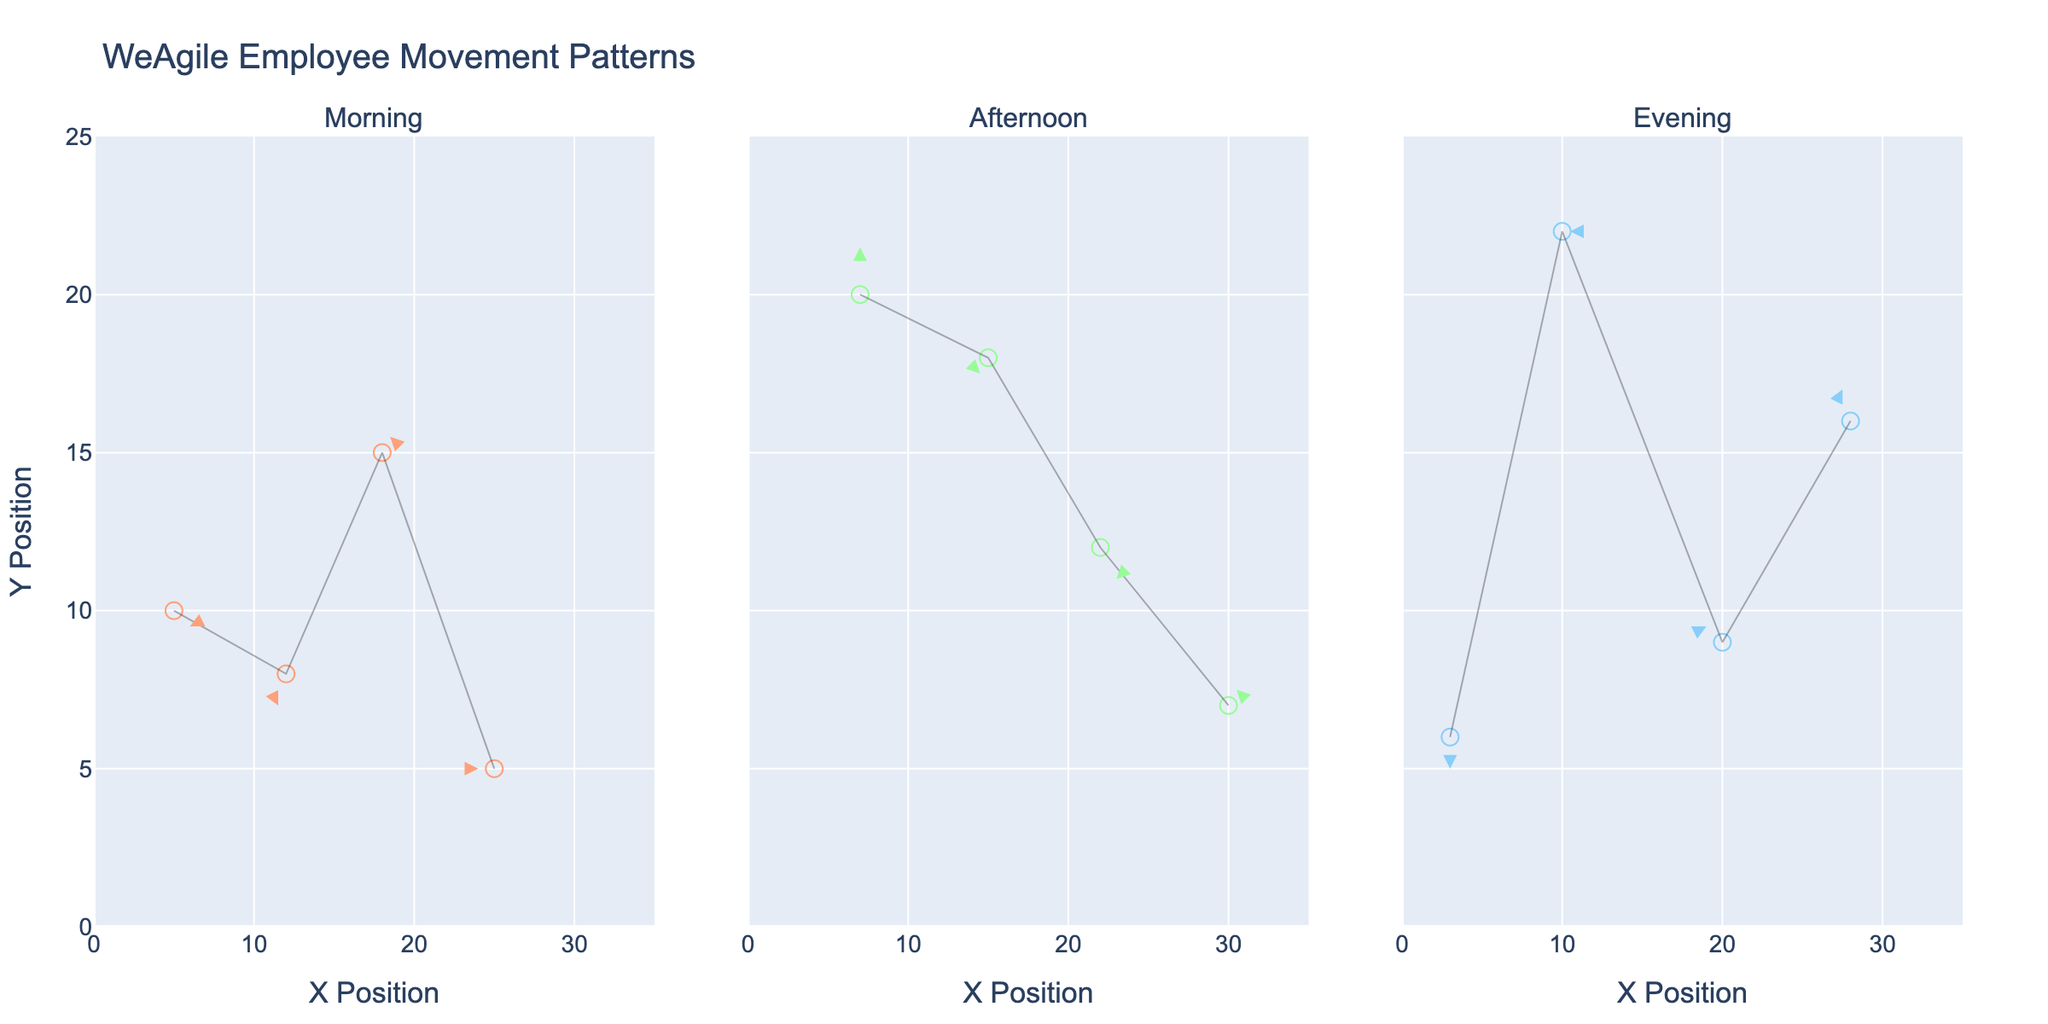Which time period shows the highest Y position movement? To determine the highest Y position movement, observe the Y values for each time period. In the figure, the afternoon has the highest Y position at (30, 7) and (7, 20).
Answer: Afternoon What is the direction of movement at (5, 10) in the morning? To find the movement direction, observe the arrow starting at (5, 10). The arrow’s direction from (5, 10) is (2, -1), indicating a movement to the right and down.
Answer: Right and down How many employee movement paths are shown in the evening? Count the paths shown in the evening section of the plot. Each path consists of an arrow from a starting point to an end point. There are four arrows in the evening section.
Answer: 4 Which time period shows the most horizontal movement to the right? To find the largest rightward horizontal movement, compare the horizontal components (u) in each time period. The afternoon has the longest rightward u values of 2 at (22, 12) and (30, 7).
Answer: Afternoon Compare the vertical movement at (22, 12) in the afternoon and (18, 15) in the morning. Which is greater? Observe the vertical movement (v) for these points. At (22, 12) in the afternoon, v is -2. At (18, 15) in the morning, v is 1. The movement of v=1 in the morning is greater.
Answer: Morning What is the average horizontal movement in the afternoon? First, extract the horizontal movements in the afternoon: 0, -1, 2, 1. Sum them to get 2, and divide by the number of points (4). The average horizontal movement is 0.5.
Answer: 0.5 What is the color used for indicating employee positions in the evening? Observe the color in the legend titled 'Evening Positions' to determine the color. The evening positions are marked with a light blue color.
Answer: Light blue Is there any point displacing horizontally to the left more than 1 unit in the morning? Examine the horizontal displacements (u) in the morning. No point has a horizontal displacement of less than -1 in the morning.
Answer: No Identify the time period with the smallest average vertical movement. Calculate averages for each time: Morning: (-1+ -2+1+0)/4 = -0.5, Afternoon: (3+ (-1) + (-2) + 1)/4 = 0.25, Evening: (-2+0+1+2)/4 = 0.25. Both afternoon and evening have the smallest average movement.
Answer: Afternoon and Evening 